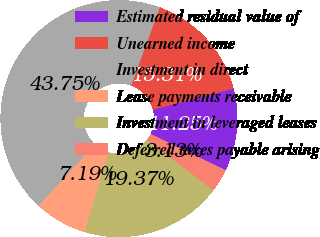<chart> <loc_0><loc_0><loc_500><loc_500><pie_chart><fcel>Estimated residual value of<fcel>Unearned income<fcel>Investment in direct<fcel>Lease payments receivable<fcel>Investment in leveraged leases<fcel>Deferred taxes payable arising<nl><fcel>11.25%<fcel>15.31%<fcel>43.75%<fcel>7.19%<fcel>19.37%<fcel>3.13%<nl></chart> 